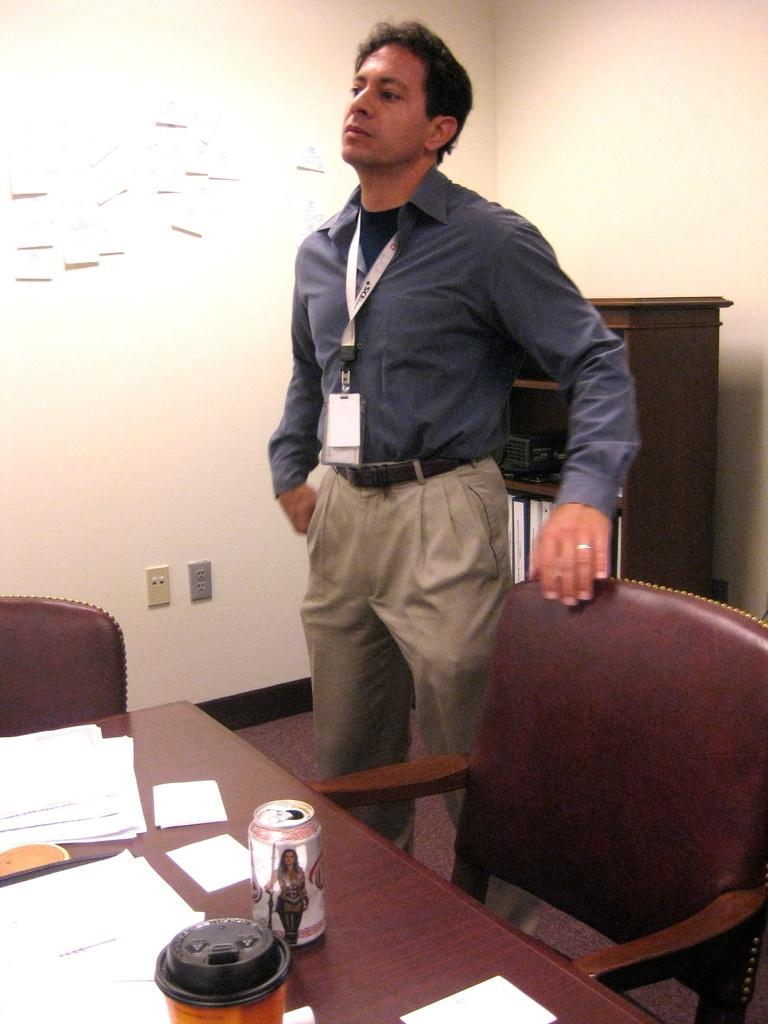What is the main subject of the image? There is a man standing in the image. What is the man wearing that is visible in the image? The man is wearing a badge. What furniture is present in the image? There is a chair and a table in the image. What is on the table in the image? There are papers on the table. What can be seen in the background of the image? There is a wall in the background of the image. How many trains can be seen in the image? There are no trains present in the image. What fact about the man's self can be determined from the image? The image does not provide any information about the man's self or personal life. 